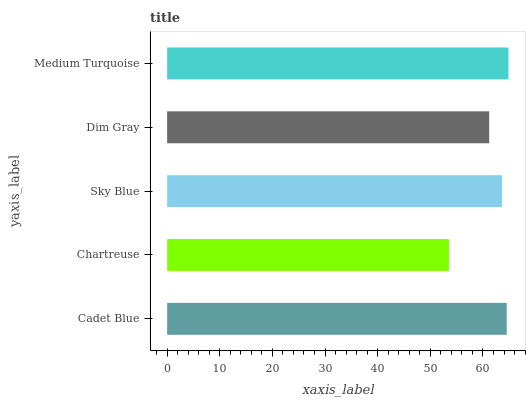Is Chartreuse the minimum?
Answer yes or no. Yes. Is Medium Turquoise the maximum?
Answer yes or no. Yes. Is Sky Blue the minimum?
Answer yes or no. No. Is Sky Blue the maximum?
Answer yes or no. No. Is Sky Blue greater than Chartreuse?
Answer yes or no. Yes. Is Chartreuse less than Sky Blue?
Answer yes or no. Yes. Is Chartreuse greater than Sky Blue?
Answer yes or no. No. Is Sky Blue less than Chartreuse?
Answer yes or no. No. Is Sky Blue the high median?
Answer yes or no. Yes. Is Sky Blue the low median?
Answer yes or no. Yes. Is Dim Gray the high median?
Answer yes or no. No. Is Dim Gray the low median?
Answer yes or no. No. 